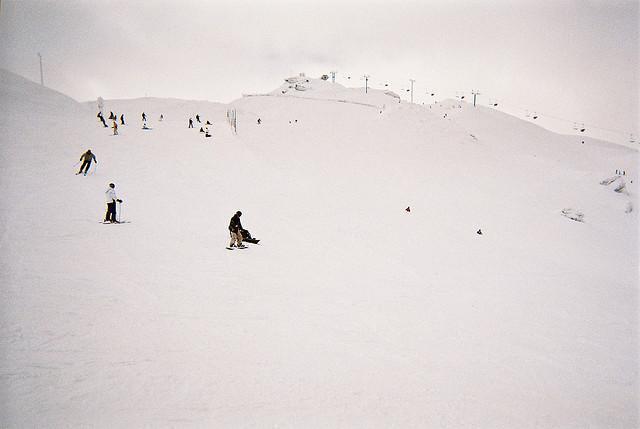What kind of sport are the people pictured above playing?
From the following four choices, select the correct answer to address the question.
Options: Ice skating, broomball, sledding, skiing. Skiing. 